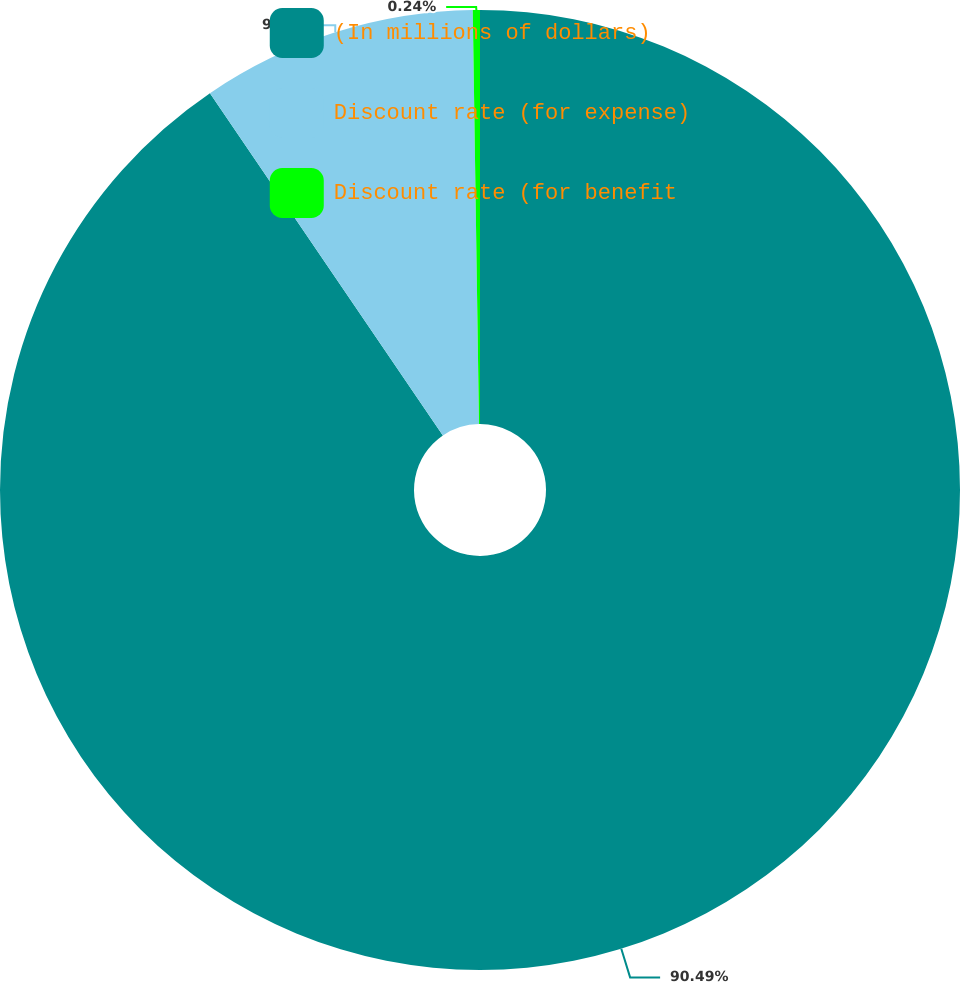<chart> <loc_0><loc_0><loc_500><loc_500><pie_chart><fcel>(In millions of dollars)<fcel>Discount rate (for expense)<fcel>Discount rate (for benefit<nl><fcel>90.49%<fcel>9.27%<fcel>0.24%<nl></chart> 